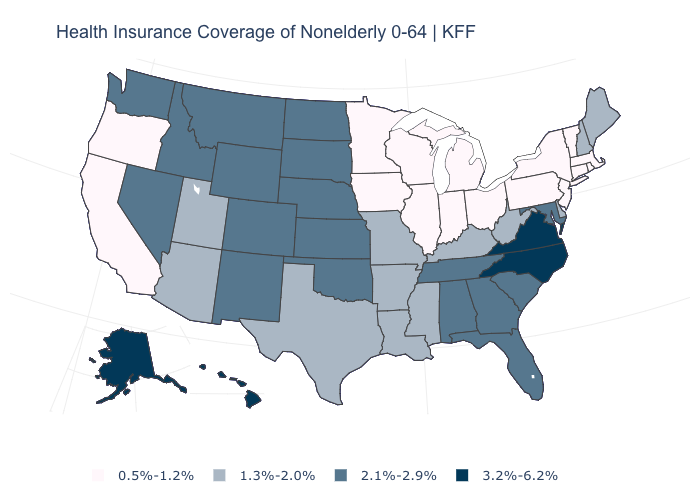What is the value of Delaware?
Answer briefly. 1.3%-2.0%. Is the legend a continuous bar?
Short answer required. No. Name the states that have a value in the range 0.5%-1.2%?
Be succinct. California, Connecticut, Illinois, Indiana, Iowa, Massachusetts, Michigan, Minnesota, New Jersey, New York, Ohio, Oregon, Pennsylvania, Rhode Island, Vermont, Wisconsin. What is the lowest value in the MidWest?
Write a very short answer. 0.5%-1.2%. Among the states that border Oklahoma , which have the lowest value?
Give a very brief answer. Arkansas, Missouri, Texas. Does Colorado have the lowest value in the West?
Write a very short answer. No. What is the value of Oklahoma?
Write a very short answer. 2.1%-2.9%. Does Kentucky have a higher value than Wisconsin?
Answer briefly. Yes. What is the lowest value in the Northeast?
Answer briefly. 0.5%-1.2%. What is the value of Delaware?
Keep it brief. 1.3%-2.0%. Name the states that have a value in the range 0.5%-1.2%?
Give a very brief answer. California, Connecticut, Illinois, Indiana, Iowa, Massachusetts, Michigan, Minnesota, New Jersey, New York, Ohio, Oregon, Pennsylvania, Rhode Island, Vermont, Wisconsin. Does New Hampshire have the lowest value in the Northeast?
Give a very brief answer. No. What is the value of Massachusetts?
Short answer required. 0.5%-1.2%. Name the states that have a value in the range 2.1%-2.9%?
Keep it brief. Alabama, Colorado, Florida, Georgia, Idaho, Kansas, Maryland, Montana, Nebraska, Nevada, New Mexico, North Dakota, Oklahoma, South Carolina, South Dakota, Tennessee, Washington, Wyoming. Does the first symbol in the legend represent the smallest category?
Short answer required. Yes. 